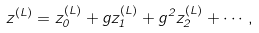Convert formula to latex. <formula><loc_0><loc_0><loc_500><loc_500>z ^ { ( L ) } = z ^ { ( L ) } _ { 0 } + g z ^ { ( L ) } _ { 1 } + g ^ { 2 } z ^ { ( L ) } _ { 2 } + \cdots ,</formula> 